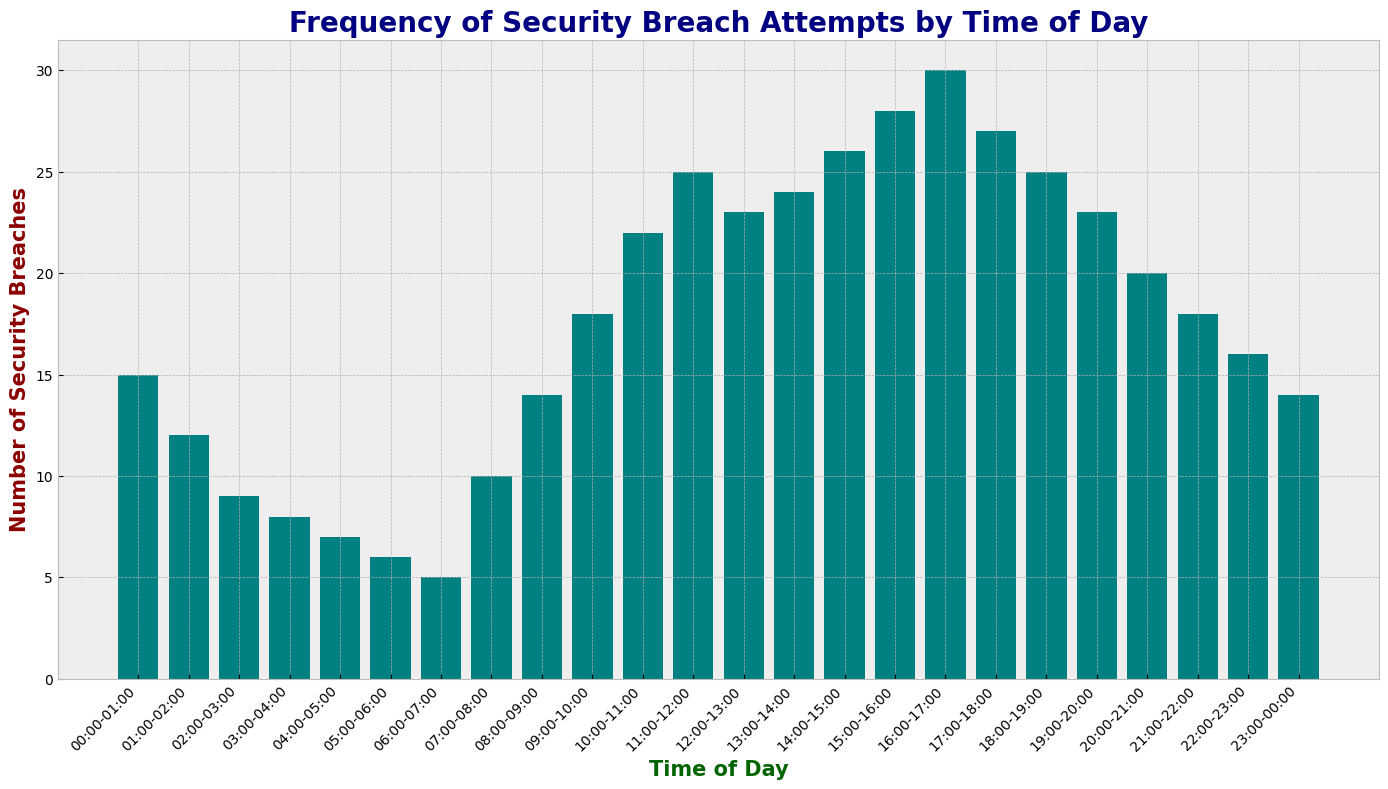What time of day has the highest number of security breaches? To determine the time of day with the highest number of security breaches, we need to identify the bar with the greatest height and read the corresponding time. The highest bar corresponds to the 16:00-17:00 time slot.
Answer: 16:00-17:00 Which hours have security breaches above 20? Identify all bars with a height indicating a value greater than 20 and list their corresponding time slots. These time slots are 10:00-11:00, 11:00-12:00, 12:00-13:00, 13:00-14:00, 14:00-15:00, 15:00-16:00, 16:00-17:00, 17:00-18:00, 18:00-19:00, and 19:00-20:00.
Answer: 10:00-20:00 (with exceptions at 17:00-18:00 and 18:00-19:00) How does the number of security breaches at 06:00-07:00 compare to 22:00-23:00? Compare the heights of the bars for the 06:00-07:00 and 22:00-23:00 time slots. The bar at 06:00-07:00 represents 5 breaches, while the bar at 22:00-23:00 represents 16 breaches. Breaches at 22:00-23:00 are greater.
Answer: 22:00-23:00 is greater What is the total number of security breaches between 10:00 and 14:00? Sum the values represented by the bars for the time slots from 10:00-11:00 to 13:00-14:00. These values are 22, 25, 23, and 24. Summing them up gives 94.
Answer: 94 What is the average number of security breaches between 00:00 and 06:00? Sum the values for the time slots from 00:00-01:00 to 05:00-06:00, then divide by the number of time slots. The values are 15, 12, 9, 8, 7, and 6. The sum is 57, and there are 6 time slots, so the average is 57/6, which equals 9.5.
Answer: 9.5 Are there any hours where the number of security breaches decreases from the previous hour? To determine this, compare the number of security breaches for each hour with the previous hour. The decreases occur at 01:00-02:00 from 00:00-01:00, 02:00-03:00 from 01:00-02:00, 03:00-04:00 from 02:00-03:00, and 04:00-05:00 from 03:00-04:00, 05:00-06:00 from 04:00-05:00, and 06:00-07:00 from 05:00-06:00.
Answer: 01:00-07:00 At what time of day do security breaches increase most rapidly? Look for the biggest jump in the height of the bars from one time slot to the next. The bars increase most rapidly between 15:00-16:00 and 16:00-17:00, where the number of breaches goes from 28 to 30, showing an increase of 2 breaches.
Answer: 15:00-16:00 to 16:00-17:00 How does the number of breaches between 07:00 and 08:00 compare with those between 08:00 and 09:00? Compare the heights of the bars for the 07:00-08:00 and 08:00-09:00 time slots. The bar for 07:00-08:00 is 10 breaches, and the bar for 08:00-09:00 is 14 breaches. Breaches are greater between 08:00 and 09:00.
Answer: 08:00-09:00 is greater What is the difference in the number of breaches between the peak hour and the hour with the fewest breaches? The peak hour is 16:00-17:00 with 30 breaches, and the hour with the fewest breaches is 06:00-07:00 with 5 breaches. The difference is 30 - 5 = 25.
Answer: 25 What is the sum of the number of breaches between 20:00 and 23:00? Sum the values represented by the bars for the time slots 20:00-21:00, 21:00-22:00, and 22:00-23:00. These values are 20, 18, and 16. The sum is 20 + 18 + 16 = 54.
Answer: 54 